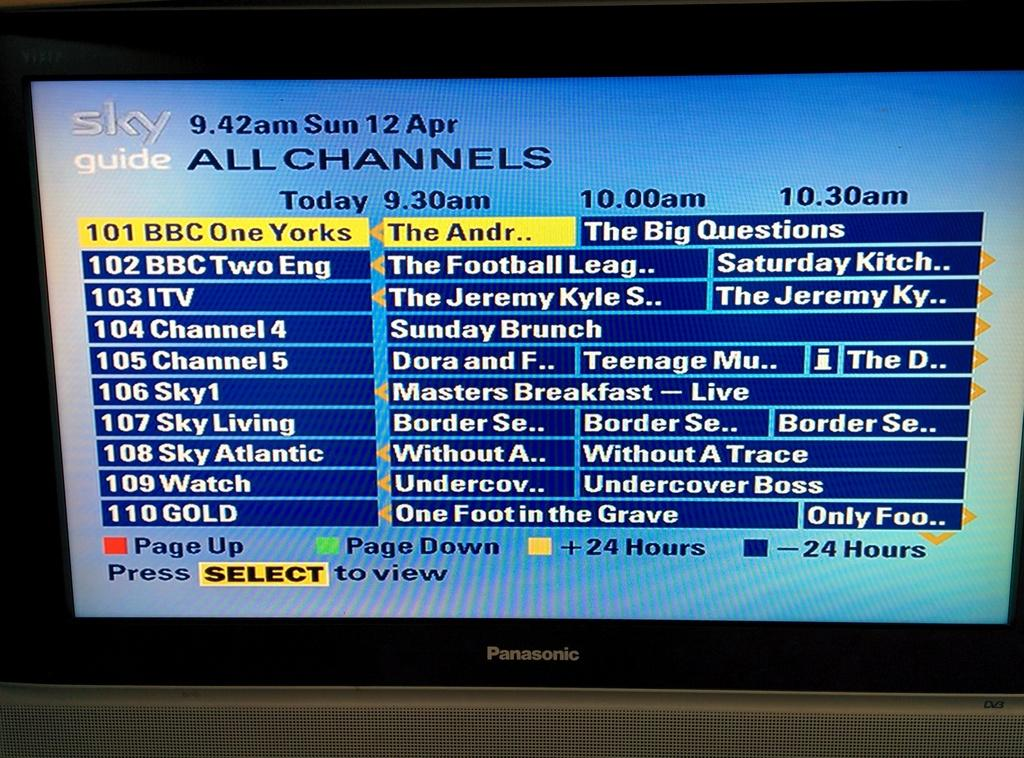<image>
Provide a brief description of the given image. A blue screen displays all channels and a schedule for today at 9:30 am. 